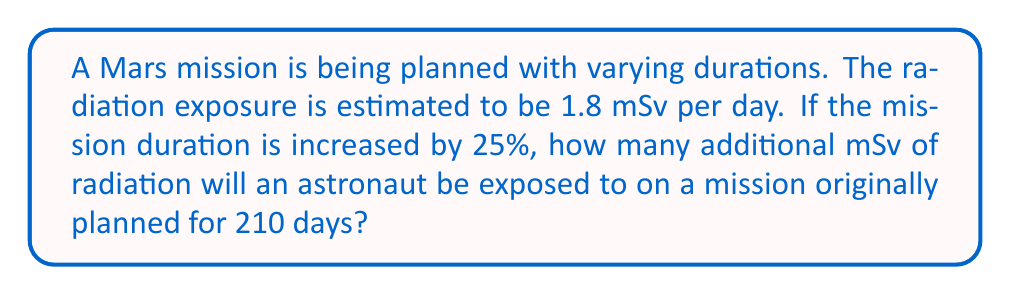Teach me how to tackle this problem. Let's approach this step-by-step:

1) First, we need to calculate the original mission duration in days:
   Original duration = 210 days

2) Next, we calculate the increase in mission duration:
   Increase = 25% = 0.25
   Additional days = 210 * 0.25 = 52.5 days

3) Now, we calculate the total radiation exposure for these additional days:
   Daily radiation exposure = 1.8 mSv/day
   Additional radiation exposure = 1.8 mSv/day * 52.5 days

4) Let's compute this:
   $$ \text{Additional exposure} = 1.8 \frac{\text{mSv}}{\text{day}} \times 52.5 \text{ days} = 94.5 \text{ mSv} $$

Therefore, the astronaut will be exposed to an additional 94.5 mSv of radiation due to the 25% increase in mission duration.
Answer: 94.5 mSv 